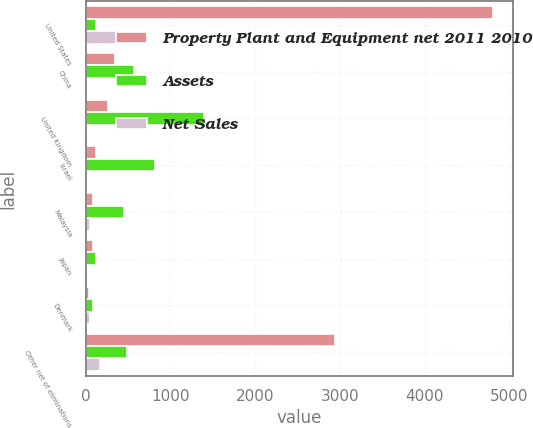<chart> <loc_0><loc_0><loc_500><loc_500><stacked_bar_chart><ecel><fcel>United States<fcel>China<fcel>United Kingdom<fcel>Israel<fcel>Malaysia<fcel>Japan<fcel>Denmark<fcel>Other net of eliminations<nl><fcel>Property Plant and Equipment net 2011 2010<fcel>4807<fcel>344<fcel>263<fcel>119<fcel>92<fcel>88<fcel>44<fcel>2941<nl><fcel>Assets<fcel>127<fcel>570<fcel>1393<fcel>823<fcel>448<fcel>127<fcel>90<fcel>485<nl><fcel>Net Sales<fcel>505<fcel>13<fcel>19<fcel>22<fcel>54<fcel>5<fcel>52<fcel>169<nl></chart> 